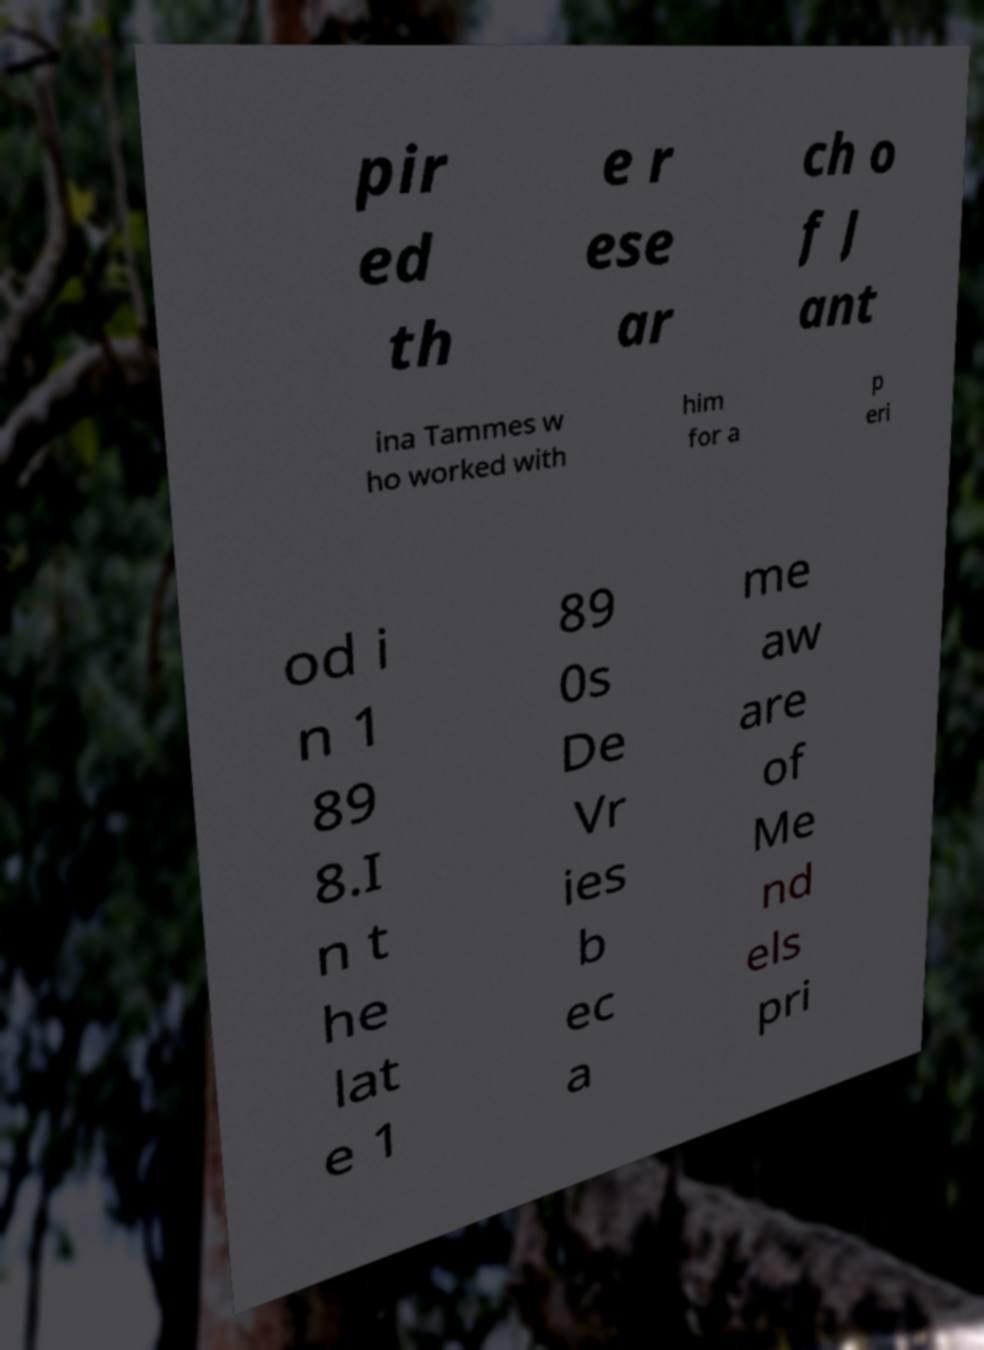Could you assist in decoding the text presented in this image and type it out clearly? pir ed th e r ese ar ch o f J ant ina Tammes w ho worked with him for a p eri od i n 1 89 8.I n t he lat e 1 89 0s De Vr ies b ec a me aw are of Me nd els pri 